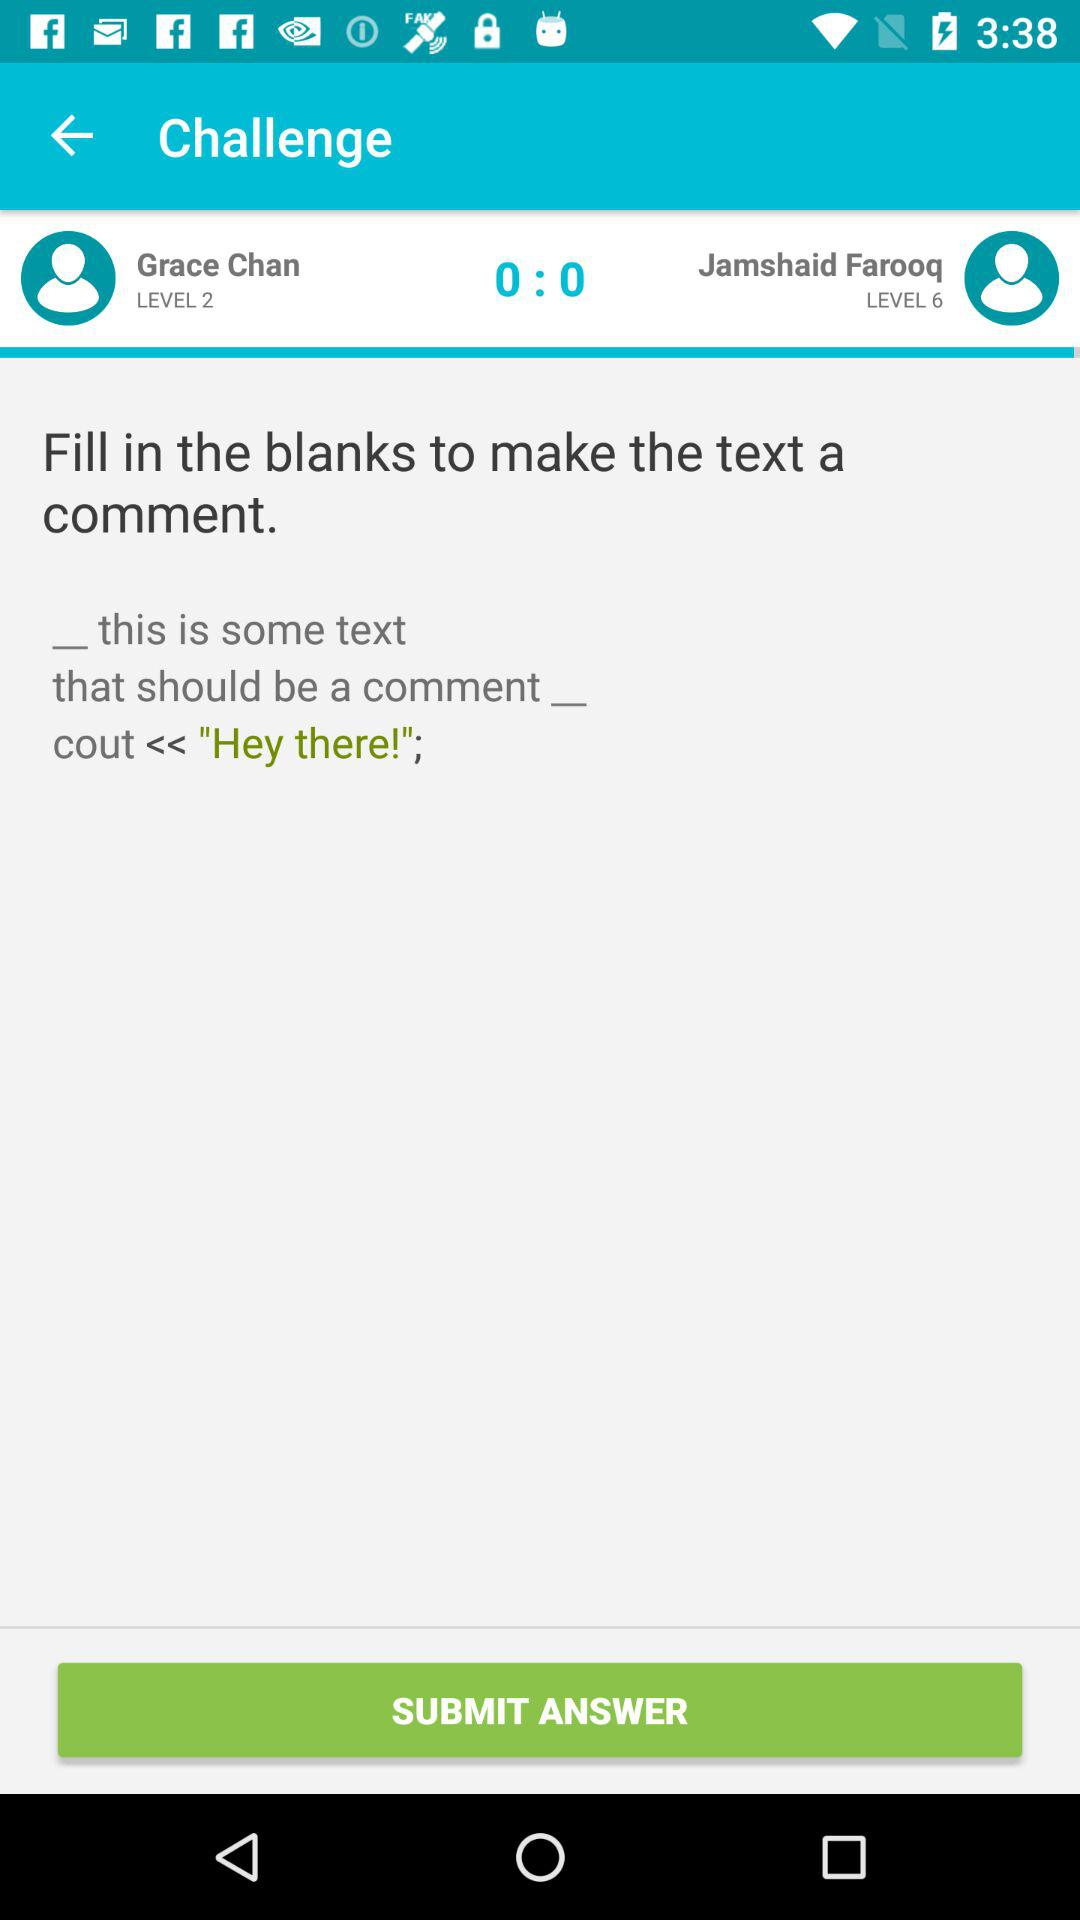How many more levels does Jamshaid Farooq have than Grace Chan?
Answer the question using a single word or phrase. 4 